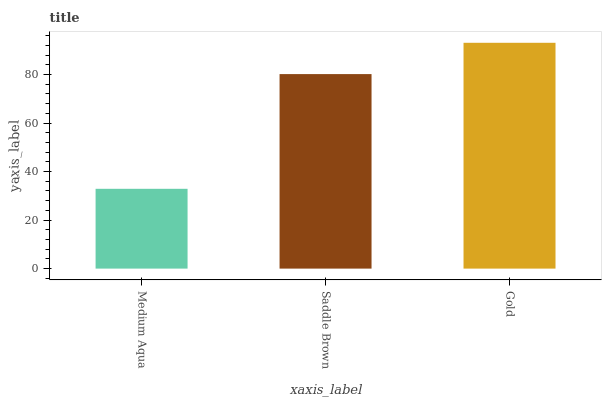Is Medium Aqua the minimum?
Answer yes or no. Yes. Is Gold the maximum?
Answer yes or no. Yes. Is Saddle Brown the minimum?
Answer yes or no. No. Is Saddle Brown the maximum?
Answer yes or no. No. Is Saddle Brown greater than Medium Aqua?
Answer yes or no. Yes. Is Medium Aqua less than Saddle Brown?
Answer yes or no. Yes. Is Medium Aqua greater than Saddle Brown?
Answer yes or no. No. Is Saddle Brown less than Medium Aqua?
Answer yes or no. No. Is Saddle Brown the high median?
Answer yes or no. Yes. Is Saddle Brown the low median?
Answer yes or no. Yes. Is Gold the high median?
Answer yes or no. No. Is Gold the low median?
Answer yes or no. No. 